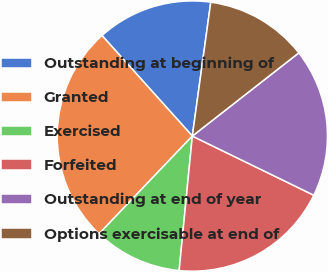Convert chart to OTSL. <chart><loc_0><loc_0><loc_500><loc_500><pie_chart><fcel>Outstanding at beginning of<fcel>Granted<fcel>Exercised<fcel>Forfeited<fcel>Outstanding at end of year<fcel>Options exercisable at end of<nl><fcel>13.83%<fcel>26.22%<fcel>10.57%<fcel>19.34%<fcel>17.77%<fcel>12.26%<nl></chart> 